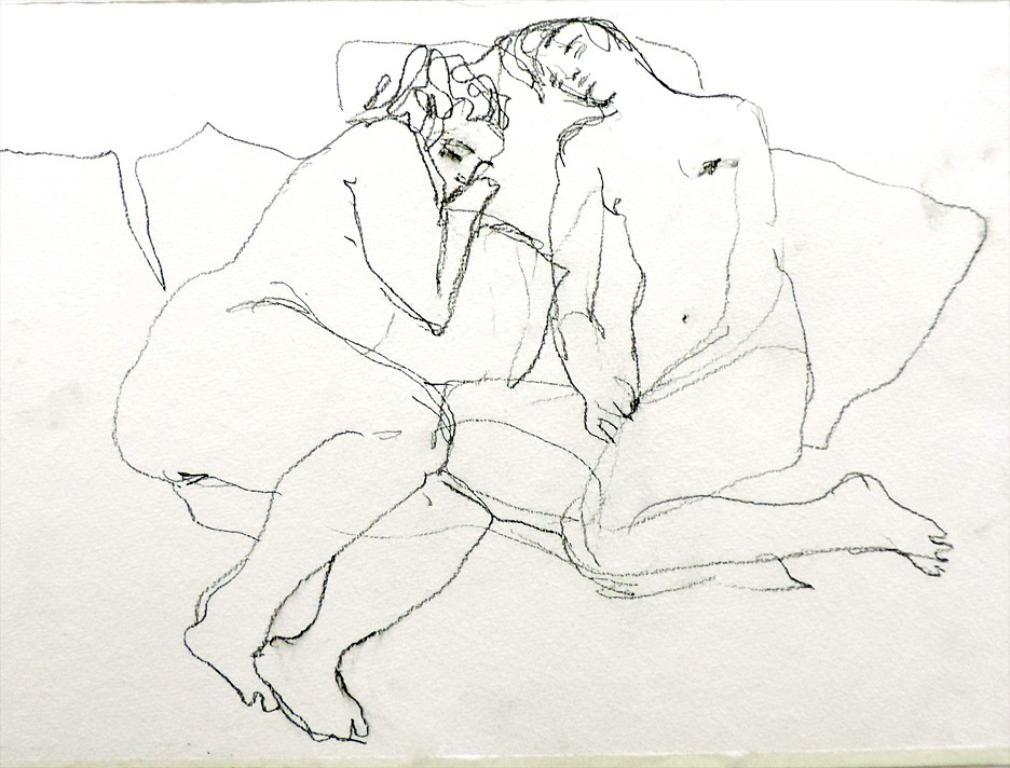What is the main subject in the middle of the image? There is a drawing image in the middle of the image. What does the drawing image depict? The drawing image depicts persons. What month is depicted in the drawing image? The drawing image does not depict a month; it depicts persons. How many times has the drawing image been folded? The drawing image has not been folded; it is a flat image in the middle of the picture. 